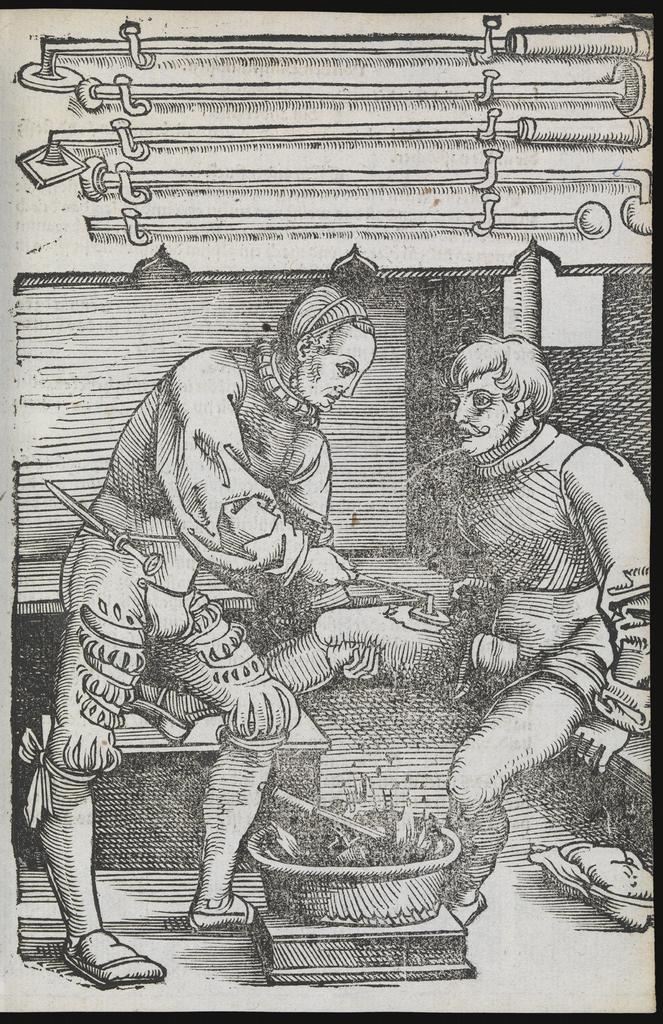What is present on the poster in the image? There is a poster in the image. What can be seen on the poster? The poster contains images of multiple persons. Can you describe any other elements on the poster besides the images of persons? There is an unspecified element on the poster. How many fingers can be seen on the wing of the bird in the image? There is no bird or wing present in the image; the poster contains images of multiple persons. 